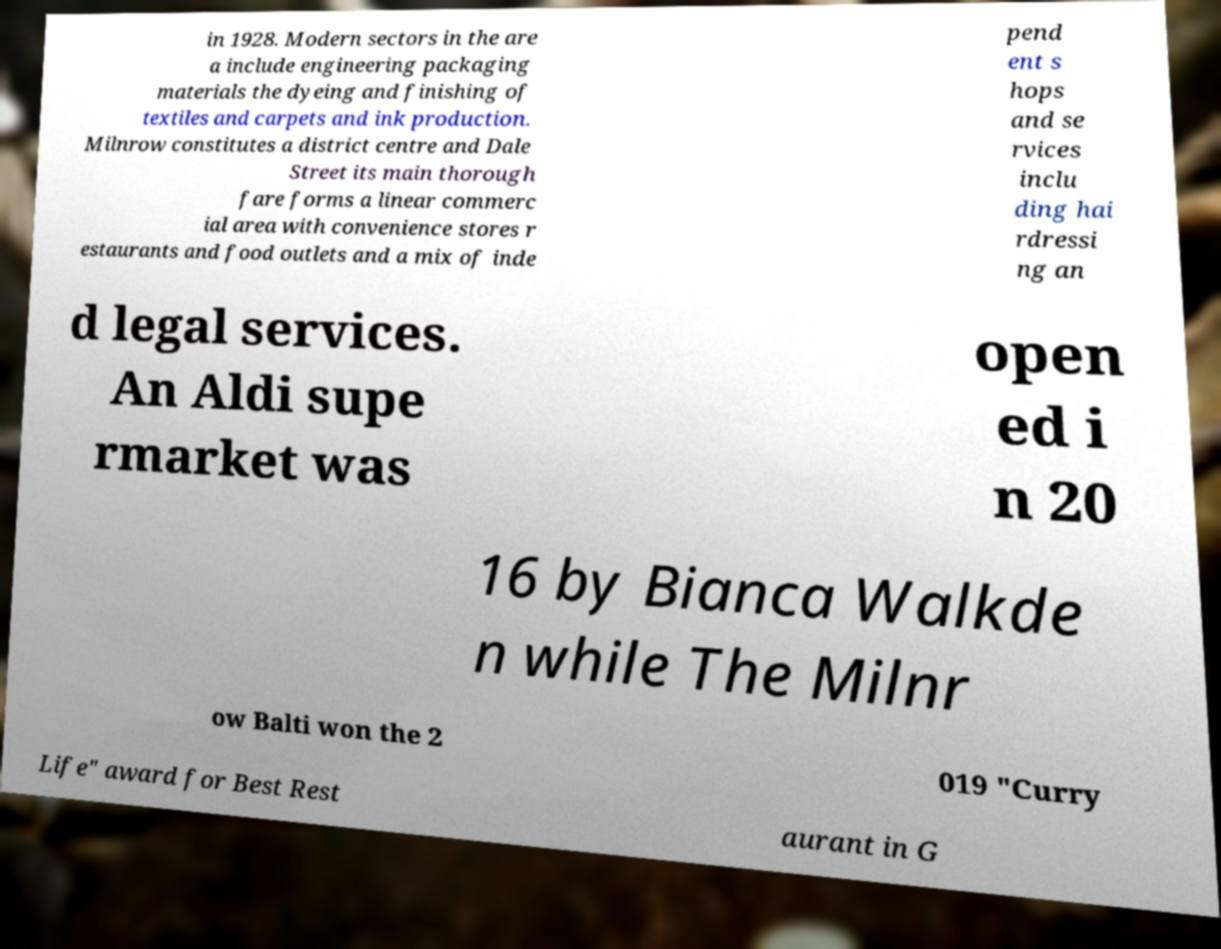Please read and relay the text visible in this image. What does it say? in 1928. Modern sectors in the are a include engineering packaging materials the dyeing and finishing of textiles and carpets and ink production. Milnrow constitutes a district centre and Dale Street its main thorough fare forms a linear commerc ial area with convenience stores r estaurants and food outlets and a mix of inde pend ent s hops and se rvices inclu ding hai rdressi ng an d legal services. An Aldi supe rmarket was open ed i n 20 16 by Bianca Walkde n while The Milnr ow Balti won the 2 019 "Curry Life" award for Best Rest aurant in G 